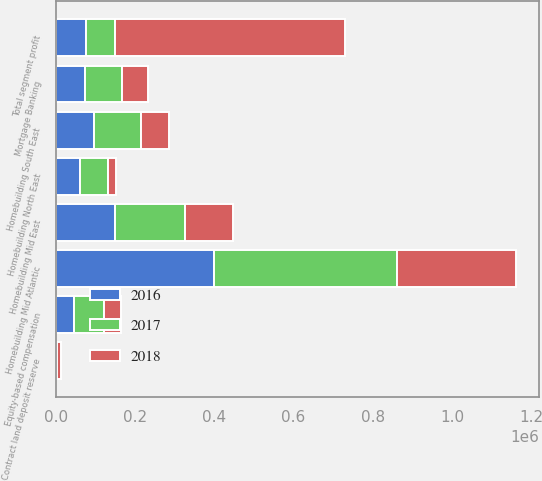<chart> <loc_0><loc_0><loc_500><loc_500><stacked_bar_chart><ecel><fcel>Homebuilding Mid Atlantic<fcel>Homebuilding North East<fcel>Homebuilding Mid East<fcel>Homebuilding South East<fcel>Mortgage Banking<fcel>Total segment profit<fcel>Contract land deposit reserve<fcel>Equity-based compensation<nl><fcel>2017<fcel>462178<fcel>69789<fcel>175134<fcel>118296<fcel>93462<fcel>74830<fcel>783<fcel>75701<nl><fcel>2016<fcel>398494<fcel>60218<fcel>149639<fcel>95826<fcel>73959<fcel>74830<fcel>1307<fcel>44562<nl><fcel>2018<fcel>301173<fcel>21947<fcel>121166<fcel>71098<fcel>63711<fcel>579095<fcel>10933<fcel>43598<nl></chart> 